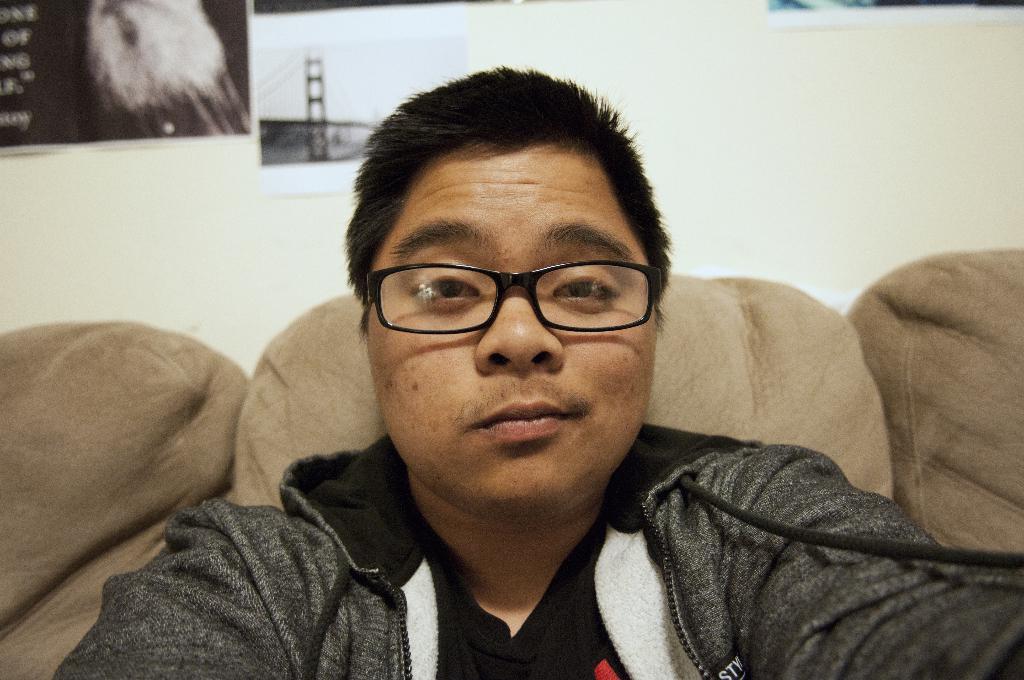Describe this image in one or two sentences. Here we can see a man and he has spectacles. There is a couch. In the background we can see wall and posters. 